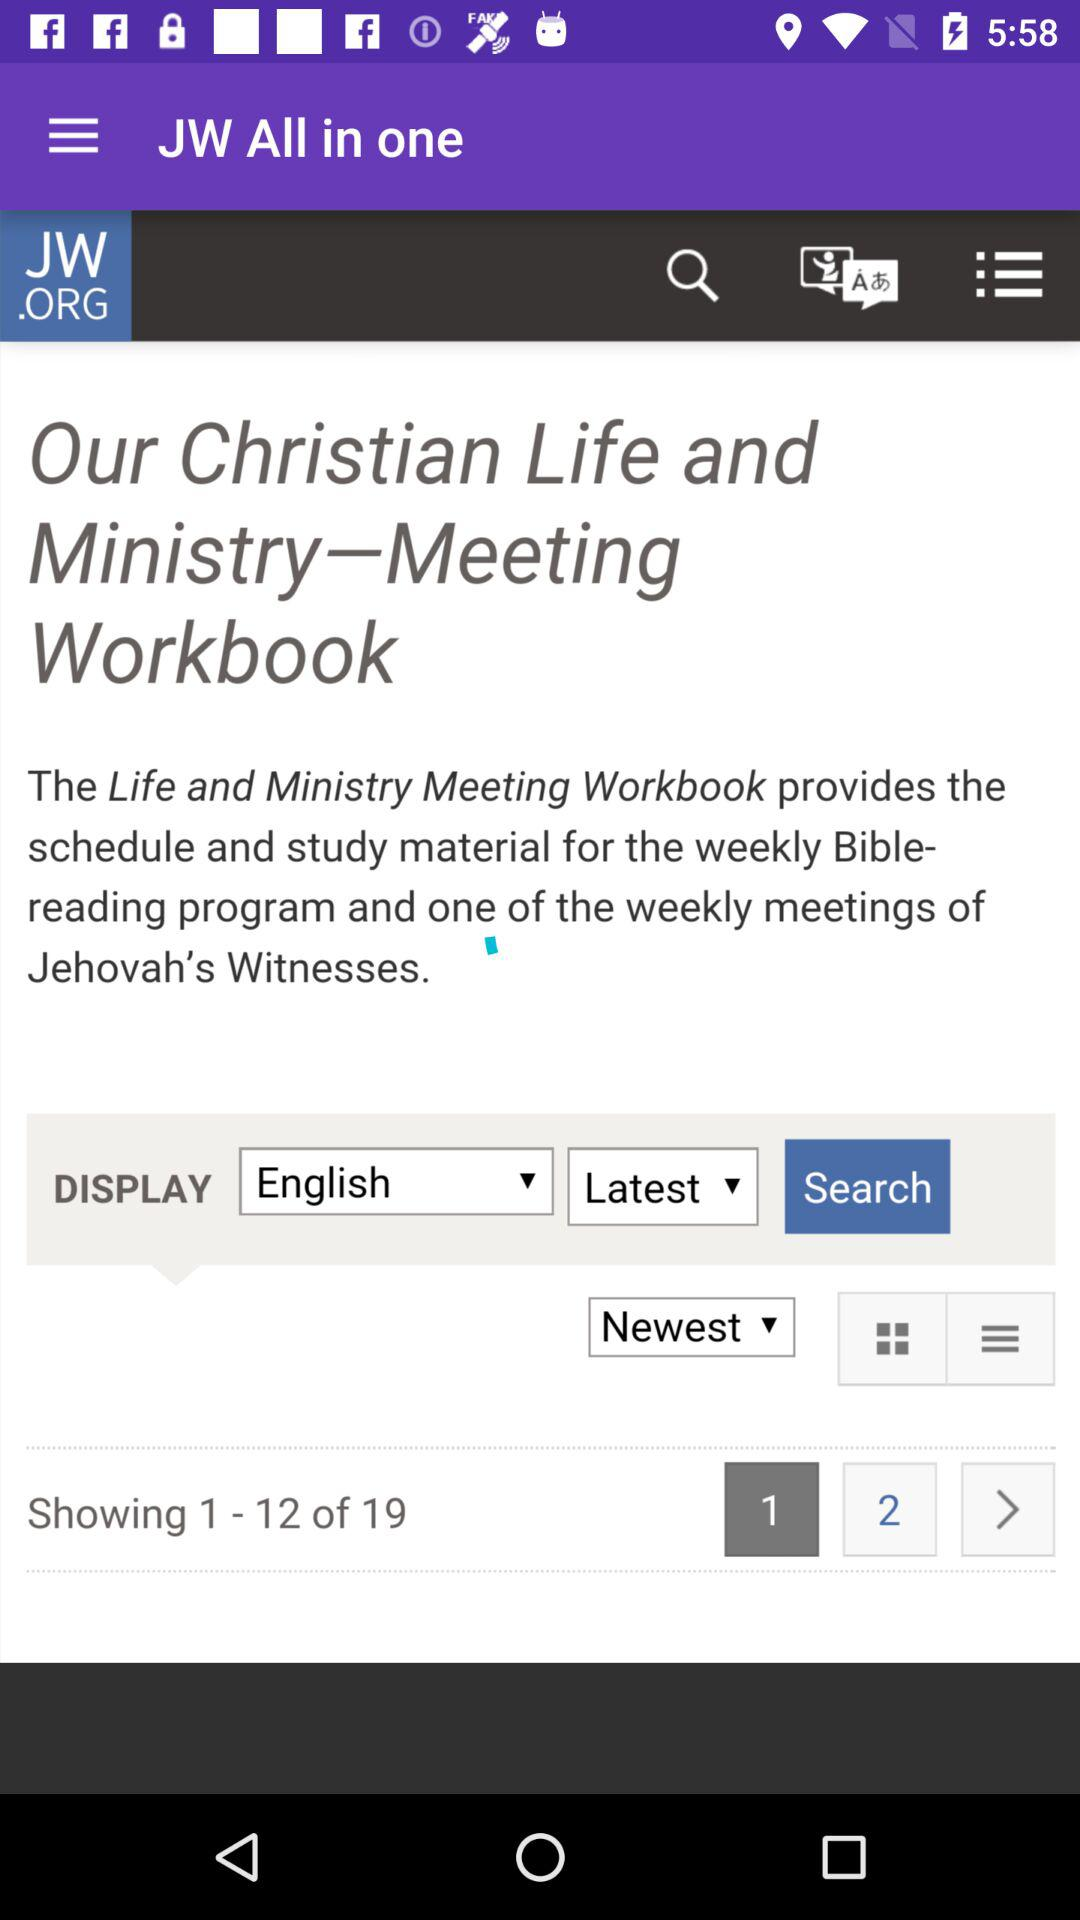What is the count of pages? The count of pages is 19. 